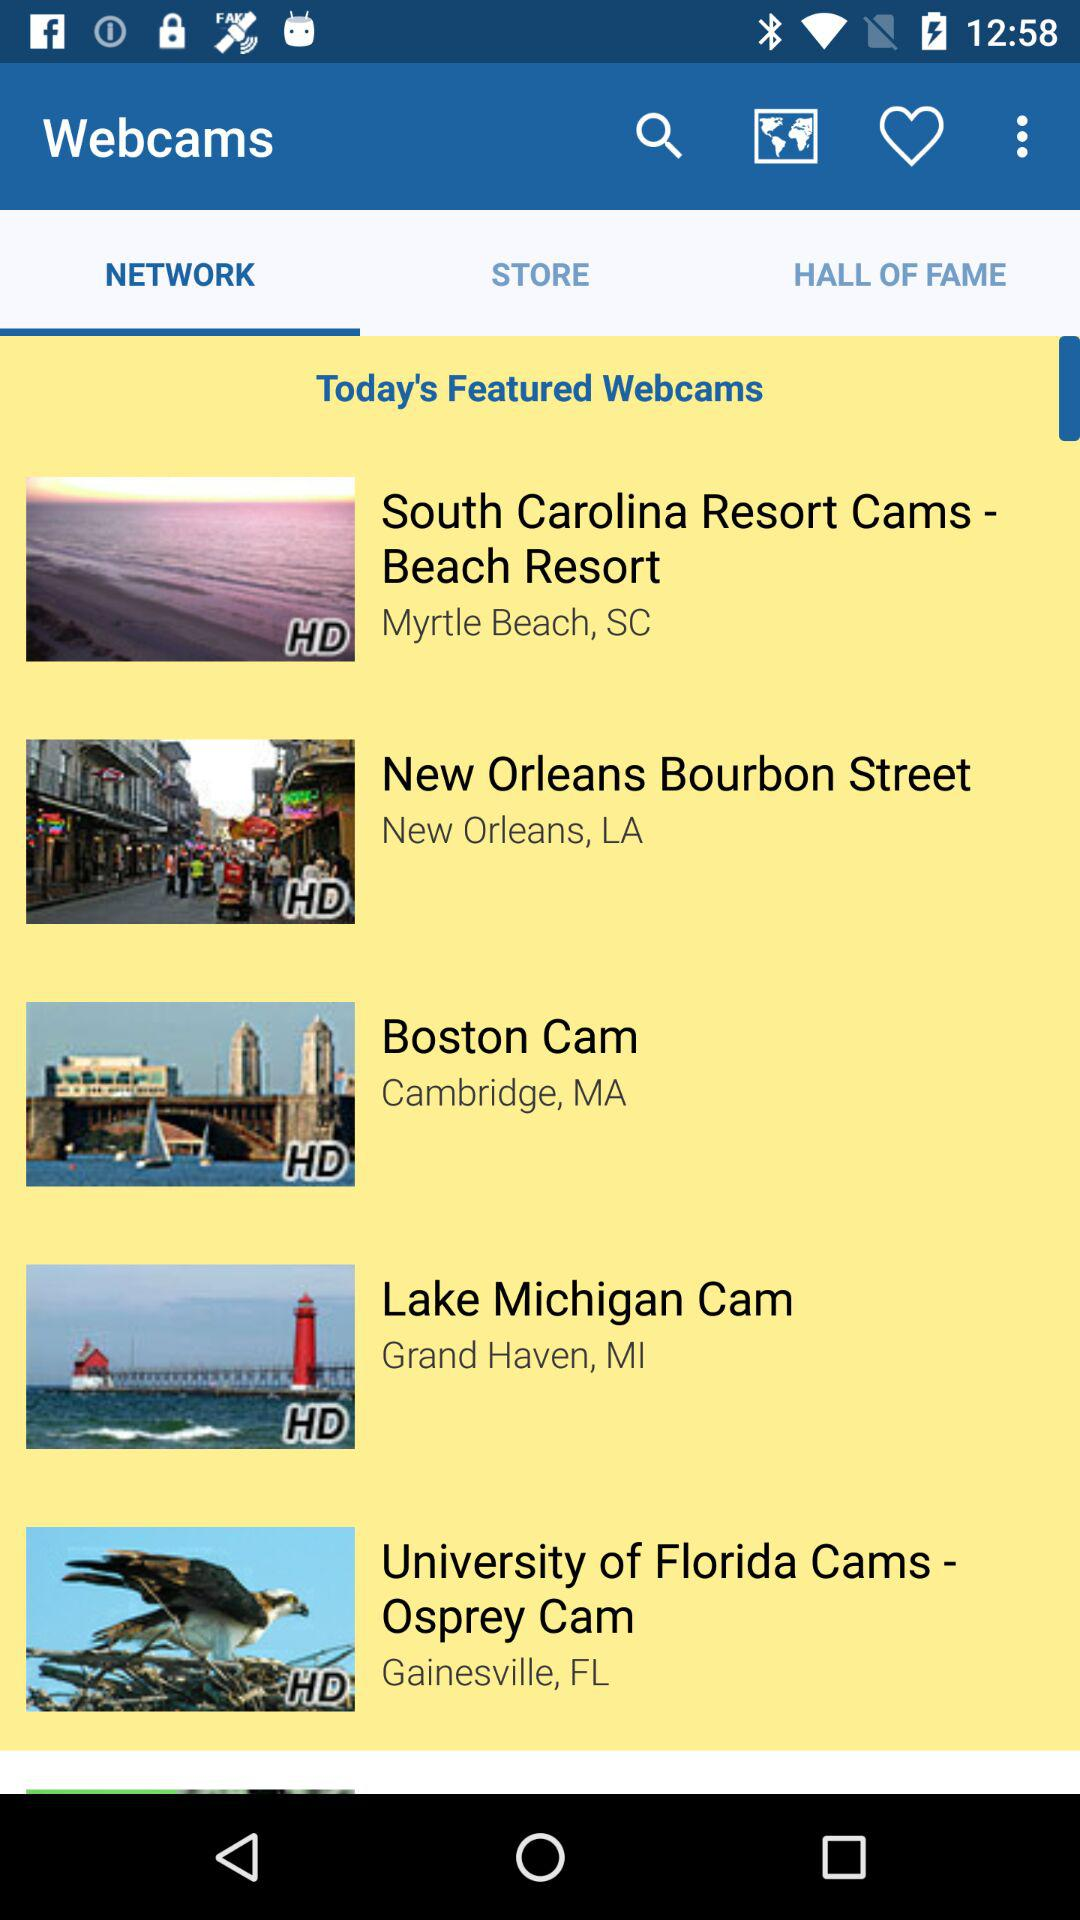Which tab has been selected? The selected tab is "NETWORK". 